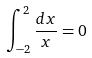Convert formula to latex. <formula><loc_0><loc_0><loc_500><loc_500>\int _ { - 2 } ^ { 2 } \frac { d x } { x } = 0</formula> 